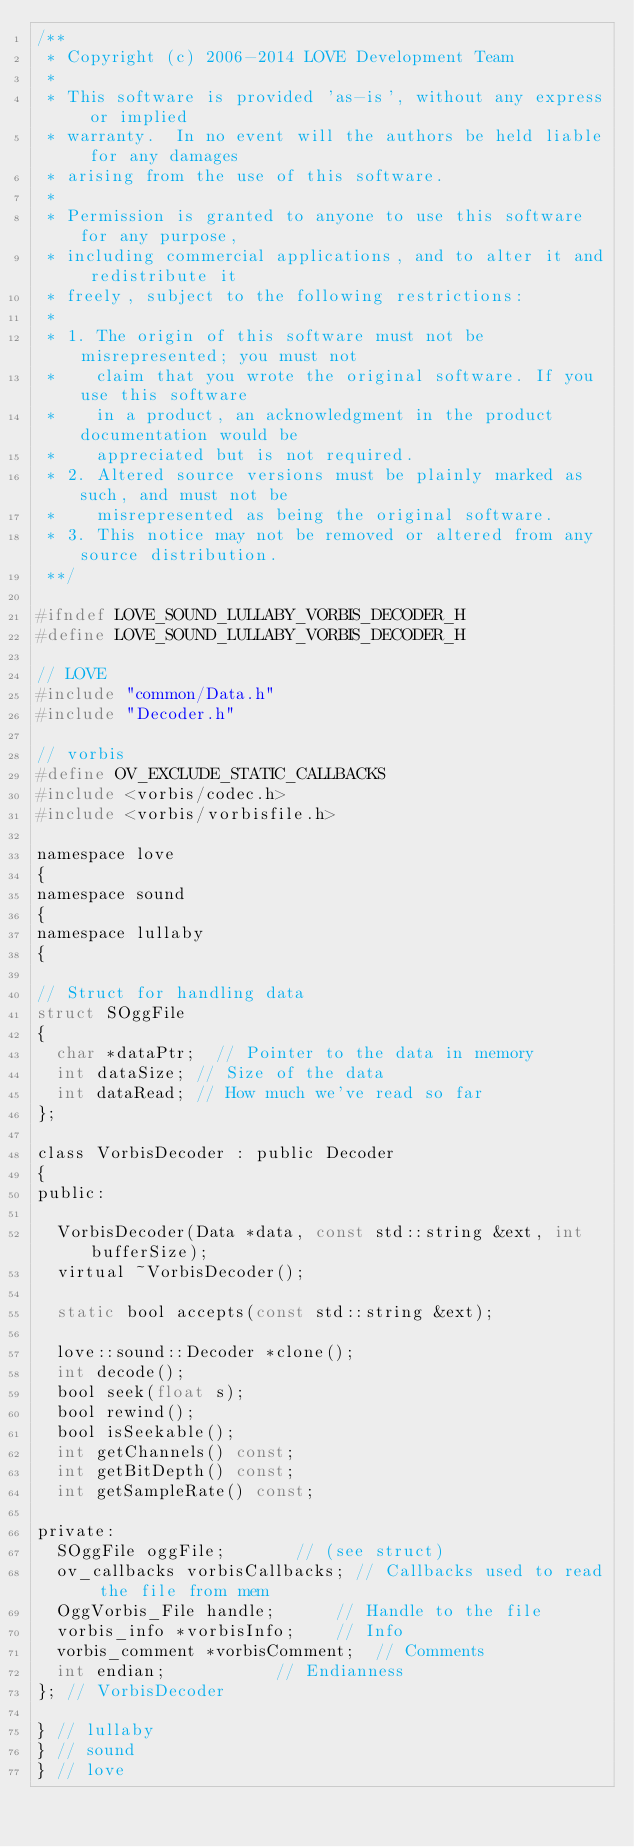Convert code to text. <code><loc_0><loc_0><loc_500><loc_500><_C_>/**
 * Copyright (c) 2006-2014 LOVE Development Team
 *
 * This software is provided 'as-is', without any express or implied
 * warranty.  In no event will the authors be held liable for any damages
 * arising from the use of this software.
 *
 * Permission is granted to anyone to use this software for any purpose,
 * including commercial applications, and to alter it and redistribute it
 * freely, subject to the following restrictions:
 *
 * 1. The origin of this software must not be misrepresented; you must not
 *    claim that you wrote the original software. If you use this software
 *    in a product, an acknowledgment in the product documentation would be
 *    appreciated but is not required.
 * 2. Altered source versions must be plainly marked as such, and must not be
 *    misrepresented as being the original software.
 * 3. This notice may not be removed or altered from any source distribution.
 **/

#ifndef LOVE_SOUND_LULLABY_VORBIS_DECODER_H
#define LOVE_SOUND_LULLABY_VORBIS_DECODER_H

// LOVE
#include "common/Data.h"
#include "Decoder.h"

// vorbis
#define OV_EXCLUDE_STATIC_CALLBACKS
#include <vorbis/codec.h>
#include <vorbis/vorbisfile.h>

namespace love
{
namespace sound
{
namespace lullaby
{

// Struct for handling data
struct SOggFile
{
	char *dataPtr;	// Pointer to the data in memory
	int dataSize;	// Size of the data
	int dataRead;	// How much we've read so far
};

class VorbisDecoder : public Decoder
{
public:

	VorbisDecoder(Data *data, const std::string &ext, int bufferSize);
	virtual ~VorbisDecoder();

	static bool accepts(const std::string &ext);

	love::sound::Decoder *clone();
	int decode();
	bool seek(float s);
	bool rewind();
	bool isSeekable();
	int getChannels() const;
	int getBitDepth() const;
	int getSampleRate() const;

private:
	SOggFile oggFile;				// (see struct)
	ov_callbacks vorbisCallbacks;	// Callbacks used to read the file from mem
	OggVorbis_File handle;			// Handle to the file
	vorbis_info *vorbisInfo;		// Info
	vorbis_comment *vorbisComment;	// Comments
	int endian;						// Endianness
}; // VorbisDecoder

} // lullaby
} // sound
} // love
</code> 